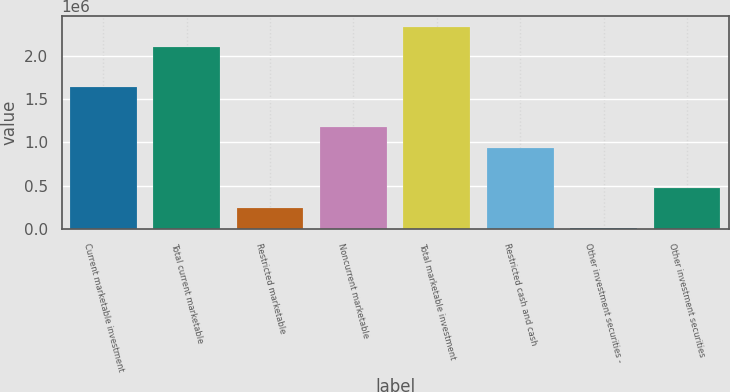Convert chart. <chart><loc_0><loc_0><loc_500><loc_500><bar_chart><fcel>Current marketable investment<fcel>Total current marketable<fcel>Restricted marketable<fcel>Noncurrent marketable<fcel>Total marketable investment<fcel>Restricted cash and cash<fcel>Other investment securities -<fcel>Other investment securities<nl><fcel>1.64249e+06<fcel>2.11097e+06<fcel>237045<fcel>1.17401e+06<fcel>2.34521e+06<fcel>939767<fcel>2805<fcel>471286<nl></chart> 